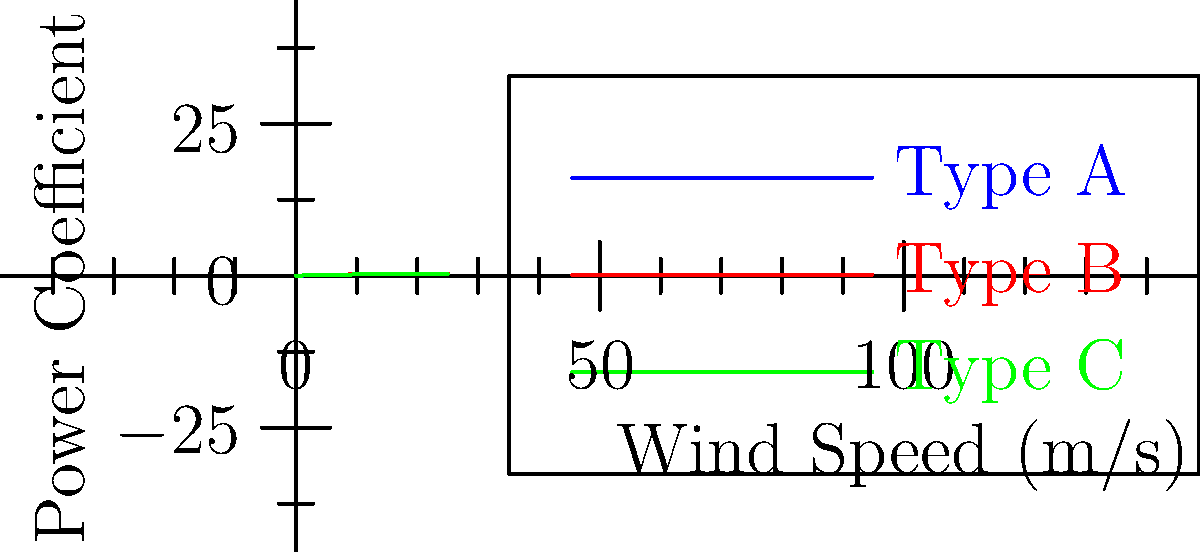The graph shows the power coefficient curves for three different wind turbine blade designs (Type A, B, and C) as a function of wind speed. Which blade design would be most efficient for a wind farm located in an area with consistently high wind speeds (above 20 m/s)? To determine the most efficient blade design for high wind speeds, we need to analyze the power coefficient curves:

1. The power coefficient (Cp) is a measure of how efficiently the turbine extracts energy from the wind.
2. A higher Cp value indicates better efficiency.
3. We're interested in wind speeds above 20 m/s.
4. Examining the graph at wind speeds above 20 m/s:
   - Type A (blue) has the highest Cp, around 0.4
   - Type B (red) has the second-highest Cp, around 0.35
   - Type C (green) has the lowest Cp, around 0.3
5. The curves appear to level off at high wind speeds, suggesting they've reached their maximum efficiency.
6. Type A maintains the highest Cp throughout the high wind speed range.

Therefore, Type A blade design would be the most efficient for consistently high wind speeds.
Answer: Type A 